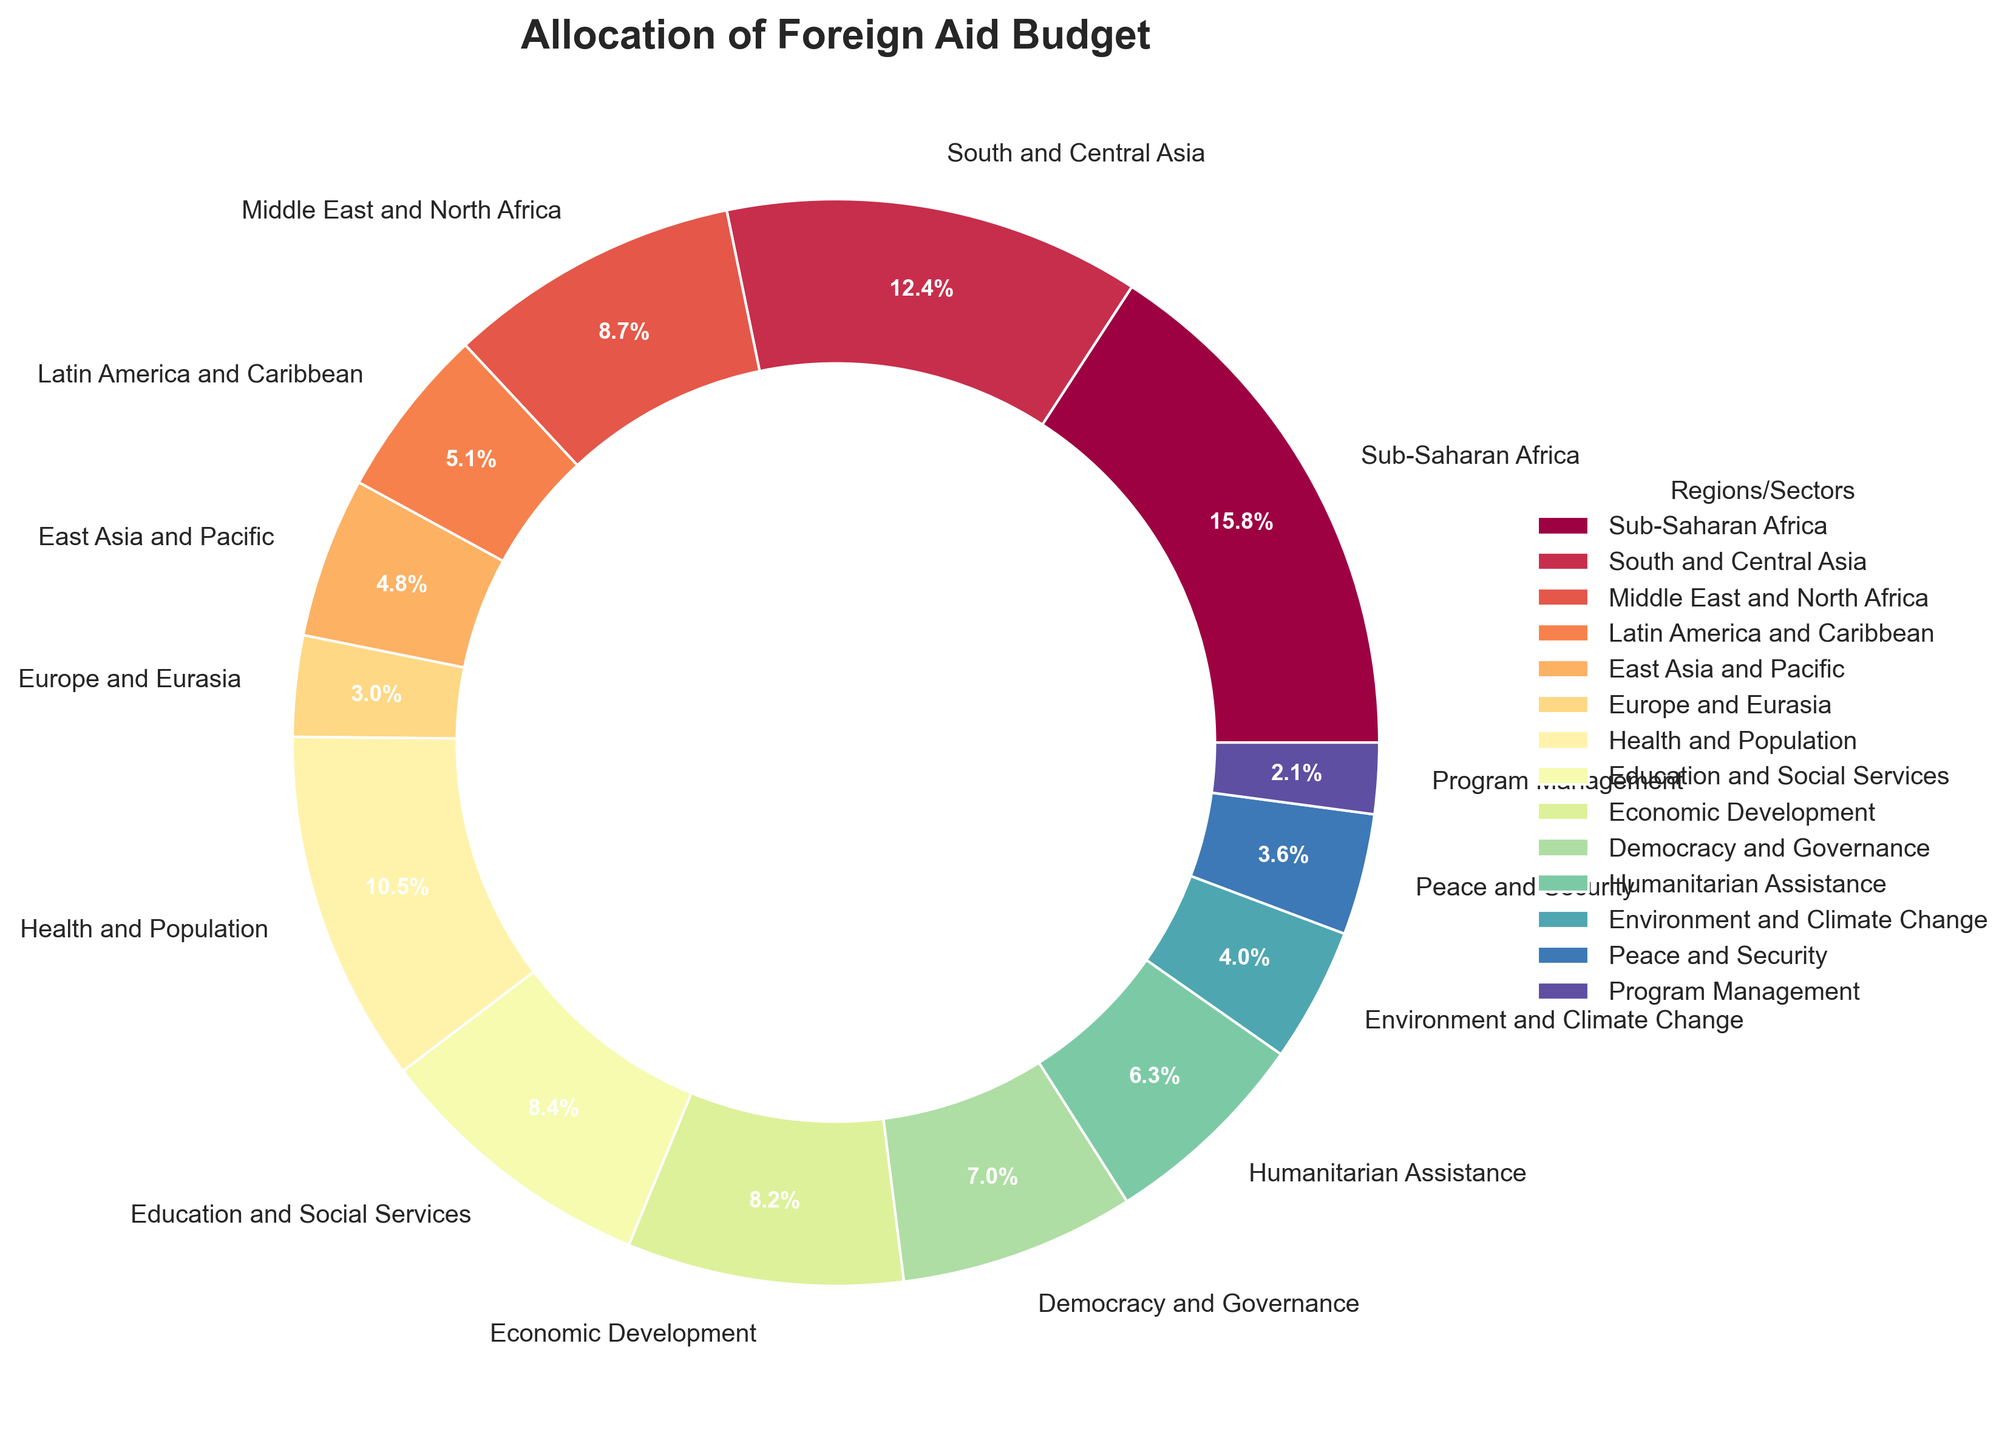Which region receives the highest percentage of the foreign aid budget? By observation, the largest segment in the pie chart indicates the highest percentage of allocation. The segment labeled "Sub-Saharan Africa" is the largest.
Answer: Sub-Saharan Africa Which two sectors combined receive over 30% of the foreign aid budget? Observing the chart, identify sectors where the sum of percentages exceeds 30%. "Health and Population" (18.9%) and "Education and Social Services" (15.2%) together make 34.1%.
Answer: Health and Population and Education and Social Services Is the budget allocation for "Health and Population" greater than that for "Democracy and Governance"? Compare the sizes, realizing "Health and Population" (18.9%) is larger than "Democracy and Governance" (12.6%).
Answer: Yes What is the combined percentage of the foreign aid budget allocated to "Economic Development" and "Humanitarian Assistance"? Sum the percentages for these sectors: "Economic Development" (14.8%) + "Humanitarian Assistance" (11.3%) = 26.1%.
Answer: 26.1% Which has a higher percentage allocation: "East Asia and Pacific" or "Middle East and North Africa"? Compare the segments. "Middle East and North Africa" (15.7%) is larger than "East Asia and Pacific" (8.6%).
Answer: Middle East and North Africa How does the allocation for "Environment and Climate Change" compare to that for "Peace and Security"? "Environment and Climate Change" has 7.2% and "Peace and Security" has 6.5%, so "Environment and Climate Change" is greater.
Answer: Environment and Climate Change What is the total percentage allocated to all sectors combined? Since sectors are different from regions, sum all sector percentages: 18.9 + 15.2 + 14.8 + 12.6 + 11.3 + 7.2 + 6.5 + 3.8 = 90.3%.
Answer: 90.3% Which segment is indicated in blue, representing around one-third of the chart? Estimate visually, the segment for "Sub-Saharan Africa" captures about a third and might be represented in blue.
Answer: Sub-Saharan Africa Calculate the difference in percentage between the allocations for "Middle East and North Africa" and "Latin America and Caribbean". Subtract their respective percentages: 15.7% - 9.2% = 6.5%.
Answer: 6.5% Identify the smallest allocated sector and its corresponding percentage. The smallest segment in size relates to "Program Management" at 3.8%.
Answer: Program Management, 3.8% 